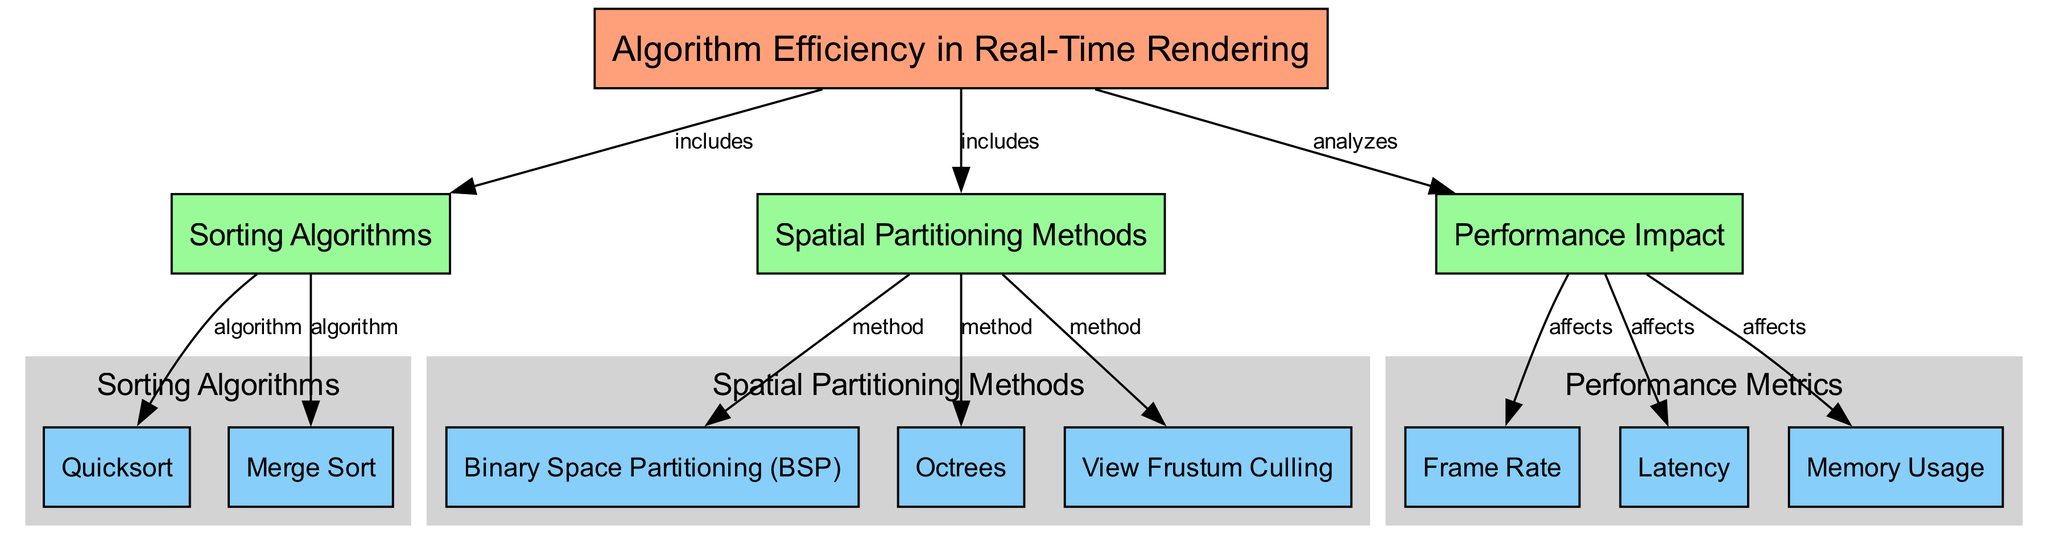What is the main topic of the diagram? The main topic is located in the first node labeled 'Algorithm Efficiency in Real-Time Rendering', which encapsulates the entire discussion of the diagram.
Answer: Algorithm Efficiency in Real-Time Rendering How many sorting algorithms are included in the diagram? The sorting algorithms are represented in node '2', which connects to two specific algorithms: 'Quicksort' and 'Merge Sort', thus totaling two algorithms.
Answer: 2 What method is associated with view frustum culling? The view frustum culling method is pointed to from node '3', which lists various spatial partitioning methods and includes 'View Frustum Culling' as a specific technique.
Answer: View Frustum Culling Which algorithm is connected to the sorting algorithms? The sorting algorithms node '2' directly connects to 'Quicksort' labeled in node '5' and 'Merge Sort' labeled in node '6', indicating they are part of the sorting algorithms.
Answer: Quicksort and Merge Sort What are the performance metrics affected by algorithm efficiency? The performance metrics are represented in node '4', which is linked to three metrics: 'Frame Rate', 'Latency', and 'Memory Usage', indicating they are all impacted by algorithm efficiency.
Answer: Frame Rate, Latency, Memory Usage Which spatial partitioning method relates to binary space partitioning? The spatial partitioning methods node '3' includes 'Binary Space Partitioning' as a specific method, directly pointing towards it from the overarching spatial partitioning category.
Answer: Binary Space Partitioning How many edges connect sorting algorithms to their respective algorithms? Two edges connect the sorting algorithms node '2' to 'Quicksort' and 'Merge Sort', indicating that there are two direct connections.
Answer: 2 What is the relationship between algorithm efficiency and performance impact? The diagram shows that the main node '1' analyzing the performance impact node '4', thus indicating that algorithm efficiency has a direct relationship impacting performance metrics.
Answer: Analyzes Which two nodes are primarily responsible for sorting algorithms? The nodes '5' (Quicksort) and '6' (Merge Sort) under the sorting algorithms cluster indicate these are the two that primarily represent sorting algorithms in the diagram.
Answer: Quicksort and Merge Sort 